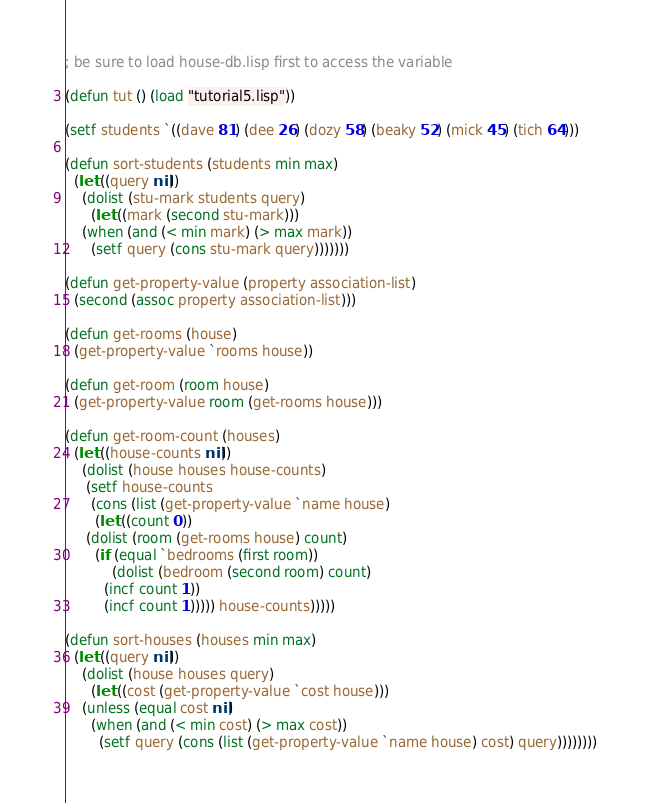Convert code to text. <code><loc_0><loc_0><loc_500><loc_500><_Lisp_>; be sure to load house-db.lisp first to access the variable

(defun tut () (load "tutorial5.lisp"))

(setf students `((dave 81) (dee 26) (dozy 58) (beaky 52) (mick 45) (tich 64)))

(defun sort-students (students min max)
  (let ((query nil))
    (dolist (stu-mark students query)
      (let ((mark (second stu-mark)))
	(when (and (< min mark) (> max mark))
	  (setf query (cons stu-mark query)))))))

(defun get-property-value (property association-list)
  (second (assoc property association-list)))

(defun get-rooms (house)
  (get-property-value `rooms house))

(defun get-room (room house)
  (get-property-value room (get-rooms house)))

(defun get-room-count (houses)
  (let ((house-counts nil))
    (dolist (house houses house-counts)
     (setf house-counts
      (cons (list (get-property-value `name house)
       (let ((count 0))
	 (dolist (room (get-rooms house) count)
	   (if (equal `bedrooms (first room))
	       (dolist (bedroom (second room) count)
		 (incf count 1))
	     (incf count 1))))) house-counts)))))

(defun sort-houses (houses min max)
  (let ((query nil))
    (dolist (house houses query)
      (let ((cost (get-property-value `cost house)))
	(unless (equal cost nil)
	  (when (and (< min cost) (> max cost))
	    (setf query (cons (list (get-property-value `name house) cost) query))))))))
</code> 